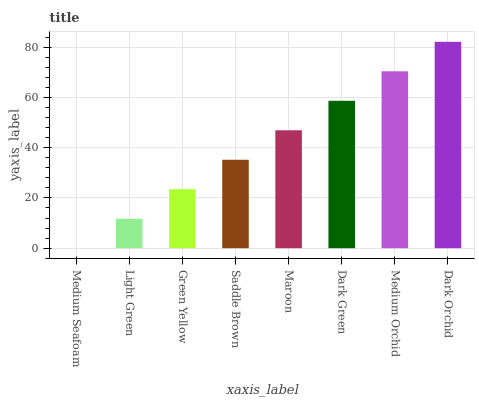Is Light Green the minimum?
Answer yes or no. No. Is Light Green the maximum?
Answer yes or no. No. Is Light Green greater than Medium Seafoam?
Answer yes or no. Yes. Is Medium Seafoam less than Light Green?
Answer yes or no. Yes. Is Medium Seafoam greater than Light Green?
Answer yes or no. No. Is Light Green less than Medium Seafoam?
Answer yes or no. No. Is Maroon the high median?
Answer yes or no. Yes. Is Saddle Brown the low median?
Answer yes or no. Yes. Is Saddle Brown the high median?
Answer yes or no. No. Is Dark Green the low median?
Answer yes or no. No. 